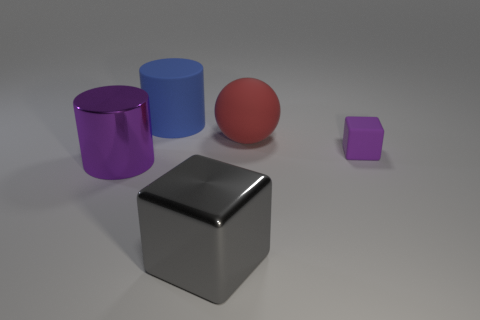Do the tiny block and the large metal cylinder have the same color?
Your answer should be compact. Yes. Does the tiny object have the same color as the large cylinder in front of the red sphere?
Offer a terse response. Yes. There is another cylinder that is the same size as the blue rubber cylinder; what is it made of?
Your response must be concise. Metal. What is the material of the block that is the same color as the metal cylinder?
Offer a terse response. Rubber. Does the red ball have the same material as the cube that is on the left side of the big red thing?
Ensure brevity in your answer.  No. How many other large metallic objects have the same shape as the big blue thing?
Your answer should be very brief. 1. There is a thing that is both in front of the big sphere and to the left of the big cube; what color is it?
Provide a short and direct response. Purple. What number of blue balls are there?
Ensure brevity in your answer.  0. Does the metal cylinder have the same size as the purple block?
Your answer should be very brief. No. Are there any big cylinders that have the same color as the tiny thing?
Your response must be concise. Yes. 